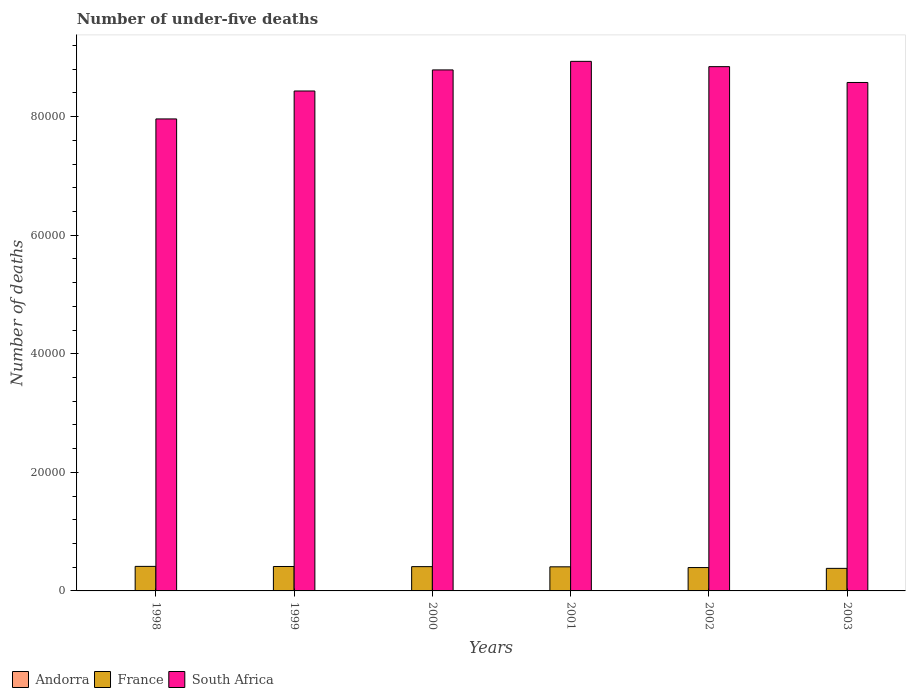How many groups of bars are there?
Ensure brevity in your answer.  6. Are the number of bars on each tick of the X-axis equal?
Offer a terse response. Yes. How many bars are there on the 4th tick from the right?
Your answer should be compact. 3. What is the label of the 3rd group of bars from the left?
Make the answer very short. 2000. Across all years, what is the maximum number of under-five deaths in France?
Your answer should be very brief. 4140. Across all years, what is the minimum number of under-five deaths in France?
Your response must be concise. 3804. In which year was the number of under-five deaths in France maximum?
Make the answer very short. 1998. What is the difference between the number of under-five deaths in France in 1998 and that in 2003?
Provide a succinct answer. 336. What is the difference between the number of under-five deaths in France in 2000 and the number of under-five deaths in Andorra in 1999?
Your response must be concise. 4093. What is the average number of under-five deaths in France per year?
Your answer should be compact. 4027.67. In the year 1998, what is the difference between the number of under-five deaths in South Africa and number of under-five deaths in France?
Give a very brief answer. 7.55e+04. Is the number of under-five deaths in South Africa in 1999 less than that in 2001?
Offer a terse response. Yes. What is the difference between the highest and the second highest number of under-five deaths in France?
Your answer should be compact. 19. What is the difference between the highest and the lowest number of under-five deaths in South Africa?
Ensure brevity in your answer.  9711. Is the sum of the number of under-five deaths in Andorra in 1998 and 2001 greater than the maximum number of under-five deaths in South Africa across all years?
Give a very brief answer. No. What does the 1st bar from the left in 2003 represents?
Make the answer very short. Andorra. What does the 2nd bar from the right in 2003 represents?
Your answer should be very brief. France. Is it the case that in every year, the sum of the number of under-five deaths in Andorra and number of under-five deaths in South Africa is greater than the number of under-five deaths in France?
Ensure brevity in your answer.  Yes. Are all the bars in the graph horizontal?
Ensure brevity in your answer.  No. How many years are there in the graph?
Offer a very short reply. 6. What is the difference between two consecutive major ticks on the Y-axis?
Your answer should be very brief. 2.00e+04. Are the values on the major ticks of Y-axis written in scientific E-notation?
Offer a very short reply. No. Does the graph contain any zero values?
Your response must be concise. No. Where does the legend appear in the graph?
Provide a short and direct response. Bottom left. How many legend labels are there?
Ensure brevity in your answer.  3. How are the legend labels stacked?
Make the answer very short. Horizontal. What is the title of the graph?
Ensure brevity in your answer.  Number of under-five deaths. Does "Turkey" appear as one of the legend labels in the graph?
Ensure brevity in your answer.  No. What is the label or title of the X-axis?
Your response must be concise. Years. What is the label or title of the Y-axis?
Ensure brevity in your answer.  Number of deaths. What is the Number of deaths of France in 1998?
Make the answer very short. 4140. What is the Number of deaths in South Africa in 1998?
Your response must be concise. 7.96e+04. What is the Number of deaths of Andorra in 1999?
Your answer should be compact. 3. What is the Number of deaths of France in 1999?
Provide a short and direct response. 4121. What is the Number of deaths in South Africa in 1999?
Provide a short and direct response. 8.43e+04. What is the Number of deaths in France in 2000?
Provide a succinct answer. 4096. What is the Number of deaths in South Africa in 2000?
Offer a very short reply. 8.79e+04. What is the Number of deaths of Andorra in 2001?
Provide a short and direct response. 3. What is the Number of deaths of France in 2001?
Your answer should be compact. 4065. What is the Number of deaths in South Africa in 2001?
Keep it short and to the point. 8.93e+04. What is the Number of deaths of Andorra in 2002?
Your answer should be compact. 3. What is the Number of deaths in France in 2002?
Give a very brief answer. 3940. What is the Number of deaths in South Africa in 2002?
Your answer should be compact. 8.84e+04. What is the Number of deaths in Andorra in 2003?
Your answer should be very brief. 3. What is the Number of deaths in France in 2003?
Offer a terse response. 3804. What is the Number of deaths in South Africa in 2003?
Provide a succinct answer. 8.58e+04. Across all years, what is the maximum Number of deaths of Andorra?
Keep it short and to the point. 3. Across all years, what is the maximum Number of deaths of France?
Offer a terse response. 4140. Across all years, what is the maximum Number of deaths in South Africa?
Ensure brevity in your answer.  8.93e+04. Across all years, what is the minimum Number of deaths of Andorra?
Give a very brief answer. 3. Across all years, what is the minimum Number of deaths of France?
Keep it short and to the point. 3804. Across all years, what is the minimum Number of deaths of South Africa?
Provide a short and direct response. 7.96e+04. What is the total Number of deaths in Andorra in the graph?
Offer a very short reply. 18. What is the total Number of deaths of France in the graph?
Give a very brief answer. 2.42e+04. What is the total Number of deaths in South Africa in the graph?
Make the answer very short. 5.15e+05. What is the difference between the Number of deaths in Andorra in 1998 and that in 1999?
Give a very brief answer. 0. What is the difference between the Number of deaths in France in 1998 and that in 1999?
Offer a very short reply. 19. What is the difference between the Number of deaths of South Africa in 1998 and that in 1999?
Keep it short and to the point. -4712. What is the difference between the Number of deaths in Andorra in 1998 and that in 2000?
Give a very brief answer. 0. What is the difference between the Number of deaths of South Africa in 1998 and that in 2000?
Your response must be concise. -8266. What is the difference between the Number of deaths in South Africa in 1998 and that in 2001?
Provide a succinct answer. -9711. What is the difference between the Number of deaths in Andorra in 1998 and that in 2002?
Offer a terse response. 0. What is the difference between the Number of deaths in South Africa in 1998 and that in 2002?
Ensure brevity in your answer.  -8818. What is the difference between the Number of deaths of Andorra in 1998 and that in 2003?
Ensure brevity in your answer.  0. What is the difference between the Number of deaths in France in 1998 and that in 2003?
Give a very brief answer. 336. What is the difference between the Number of deaths in South Africa in 1998 and that in 2003?
Provide a short and direct response. -6147. What is the difference between the Number of deaths of Andorra in 1999 and that in 2000?
Your answer should be compact. 0. What is the difference between the Number of deaths in France in 1999 and that in 2000?
Give a very brief answer. 25. What is the difference between the Number of deaths in South Africa in 1999 and that in 2000?
Your response must be concise. -3554. What is the difference between the Number of deaths in France in 1999 and that in 2001?
Give a very brief answer. 56. What is the difference between the Number of deaths of South Africa in 1999 and that in 2001?
Your answer should be compact. -4999. What is the difference between the Number of deaths in France in 1999 and that in 2002?
Your response must be concise. 181. What is the difference between the Number of deaths of South Africa in 1999 and that in 2002?
Ensure brevity in your answer.  -4106. What is the difference between the Number of deaths of Andorra in 1999 and that in 2003?
Provide a succinct answer. 0. What is the difference between the Number of deaths in France in 1999 and that in 2003?
Offer a very short reply. 317. What is the difference between the Number of deaths of South Africa in 1999 and that in 2003?
Your answer should be very brief. -1435. What is the difference between the Number of deaths of France in 2000 and that in 2001?
Offer a terse response. 31. What is the difference between the Number of deaths of South Africa in 2000 and that in 2001?
Keep it short and to the point. -1445. What is the difference between the Number of deaths in Andorra in 2000 and that in 2002?
Provide a short and direct response. 0. What is the difference between the Number of deaths of France in 2000 and that in 2002?
Ensure brevity in your answer.  156. What is the difference between the Number of deaths of South Africa in 2000 and that in 2002?
Your response must be concise. -552. What is the difference between the Number of deaths of Andorra in 2000 and that in 2003?
Your answer should be compact. 0. What is the difference between the Number of deaths in France in 2000 and that in 2003?
Offer a very short reply. 292. What is the difference between the Number of deaths in South Africa in 2000 and that in 2003?
Provide a short and direct response. 2119. What is the difference between the Number of deaths of France in 2001 and that in 2002?
Offer a very short reply. 125. What is the difference between the Number of deaths in South Africa in 2001 and that in 2002?
Provide a short and direct response. 893. What is the difference between the Number of deaths in Andorra in 2001 and that in 2003?
Provide a succinct answer. 0. What is the difference between the Number of deaths in France in 2001 and that in 2003?
Your answer should be compact. 261. What is the difference between the Number of deaths of South Africa in 2001 and that in 2003?
Your answer should be compact. 3564. What is the difference between the Number of deaths of France in 2002 and that in 2003?
Give a very brief answer. 136. What is the difference between the Number of deaths in South Africa in 2002 and that in 2003?
Ensure brevity in your answer.  2671. What is the difference between the Number of deaths of Andorra in 1998 and the Number of deaths of France in 1999?
Your response must be concise. -4118. What is the difference between the Number of deaths of Andorra in 1998 and the Number of deaths of South Africa in 1999?
Keep it short and to the point. -8.43e+04. What is the difference between the Number of deaths of France in 1998 and the Number of deaths of South Africa in 1999?
Give a very brief answer. -8.02e+04. What is the difference between the Number of deaths in Andorra in 1998 and the Number of deaths in France in 2000?
Your answer should be very brief. -4093. What is the difference between the Number of deaths in Andorra in 1998 and the Number of deaths in South Africa in 2000?
Make the answer very short. -8.79e+04. What is the difference between the Number of deaths of France in 1998 and the Number of deaths of South Africa in 2000?
Keep it short and to the point. -8.37e+04. What is the difference between the Number of deaths of Andorra in 1998 and the Number of deaths of France in 2001?
Your answer should be very brief. -4062. What is the difference between the Number of deaths of Andorra in 1998 and the Number of deaths of South Africa in 2001?
Your answer should be compact. -8.93e+04. What is the difference between the Number of deaths of France in 1998 and the Number of deaths of South Africa in 2001?
Your answer should be compact. -8.52e+04. What is the difference between the Number of deaths of Andorra in 1998 and the Number of deaths of France in 2002?
Provide a succinct answer. -3937. What is the difference between the Number of deaths of Andorra in 1998 and the Number of deaths of South Africa in 2002?
Make the answer very short. -8.84e+04. What is the difference between the Number of deaths of France in 1998 and the Number of deaths of South Africa in 2002?
Make the answer very short. -8.43e+04. What is the difference between the Number of deaths in Andorra in 1998 and the Number of deaths in France in 2003?
Provide a short and direct response. -3801. What is the difference between the Number of deaths of Andorra in 1998 and the Number of deaths of South Africa in 2003?
Keep it short and to the point. -8.58e+04. What is the difference between the Number of deaths in France in 1998 and the Number of deaths in South Africa in 2003?
Provide a succinct answer. -8.16e+04. What is the difference between the Number of deaths in Andorra in 1999 and the Number of deaths in France in 2000?
Your answer should be compact. -4093. What is the difference between the Number of deaths in Andorra in 1999 and the Number of deaths in South Africa in 2000?
Your answer should be compact. -8.79e+04. What is the difference between the Number of deaths of France in 1999 and the Number of deaths of South Africa in 2000?
Give a very brief answer. -8.38e+04. What is the difference between the Number of deaths of Andorra in 1999 and the Number of deaths of France in 2001?
Your answer should be compact. -4062. What is the difference between the Number of deaths in Andorra in 1999 and the Number of deaths in South Africa in 2001?
Make the answer very short. -8.93e+04. What is the difference between the Number of deaths in France in 1999 and the Number of deaths in South Africa in 2001?
Make the answer very short. -8.52e+04. What is the difference between the Number of deaths of Andorra in 1999 and the Number of deaths of France in 2002?
Ensure brevity in your answer.  -3937. What is the difference between the Number of deaths in Andorra in 1999 and the Number of deaths in South Africa in 2002?
Make the answer very short. -8.84e+04. What is the difference between the Number of deaths of France in 1999 and the Number of deaths of South Africa in 2002?
Provide a succinct answer. -8.43e+04. What is the difference between the Number of deaths of Andorra in 1999 and the Number of deaths of France in 2003?
Make the answer very short. -3801. What is the difference between the Number of deaths of Andorra in 1999 and the Number of deaths of South Africa in 2003?
Your response must be concise. -8.58e+04. What is the difference between the Number of deaths in France in 1999 and the Number of deaths in South Africa in 2003?
Provide a succinct answer. -8.16e+04. What is the difference between the Number of deaths of Andorra in 2000 and the Number of deaths of France in 2001?
Provide a short and direct response. -4062. What is the difference between the Number of deaths of Andorra in 2000 and the Number of deaths of South Africa in 2001?
Keep it short and to the point. -8.93e+04. What is the difference between the Number of deaths in France in 2000 and the Number of deaths in South Africa in 2001?
Your response must be concise. -8.52e+04. What is the difference between the Number of deaths in Andorra in 2000 and the Number of deaths in France in 2002?
Offer a very short reply. -3937. What is the difference between the Number of deaths in Andorra in 2000 and the Number of deaths in South Africa in 2002?
Provide a short and direct response. -8.84e+04. What is the difference between the Number of deaths in France in 2000 and the Number of deaths in South Africa in 2002?
Keep it short and to the point. -8.43e+04. What is the difference between the Number of deaths of Andorra in 2000 and the Number of deaths of France in 2003?
Offer a terse response. -3801. What is the difference between the Number of deaths of Andorra in 2000 and the Number of deaths of South Africa in 2003?
Your answer should be very brief. -8.58e+04. What is the difference between the Number of deaths of France in 2000 and the Number of deaths of South Africa in 2003?
Your answer should be compact. -8.17e+04. What is the difference between the Number of deaths of Andorra in 2001 and the Number of deaths of France in 2002?
Offer a very short reply. -3937. What is the difference between the Number of deaths of Andorra in 2001 and the Number of deaths of South Africa in 2002?
Offer a terse response. -8.84e+04. What is the difference between the Number of deaths of France in 2001 and the Number of deaths of South Africa in 2002?
Give a very brief answer. -8.44e+04. What is the difference between the Number of deaths in Andorra in 2001 and the Number of deaths in France in 2003?
Offer a very short reply. -3801. What is the difference between the Number of deaths of Andorra in 2001 and the Number of deaths of South Africa in 2003?
Your answer should be very brief. -8.58e+04. What is the difference between the Number of deaths of France in 2001 and the Number of deaths of South Africa in 2003?
Your response must be concise. -8.17e+04. What is the difference between the Number of deaths of Andorra in 2002 and the Number of deaths of France in 2003?
Make the answer very short. -3801. What is the difference between the Number of deaths in Andorra in 2002 and the Number of deaths in South Africa in 2003?
Your answer should be very brief. -8.58e+04. What is the difference between the Number of deaths of France in 2002 and the Number of deaths of South Africa in 2003?
Provide a succinct answer. -8.18e+04. What is the average Number of deaths in France per year?
Ensure brevity in your answer.  4027.67. What is the average Number of deaths of South Africa per year?
Ensure brevity in your answer.  8.59e+04. In the year 1998, what is the difference between the Number of deaths in Andorra and Number of deaths in France?
Your response must be concise. -4137. In the year 1998, what is the difference between the Number of deaths of Andorra and Number of deaths of South Africa?
Keep it short and to the point. -7.96e+04. In the year 1998, what is the difference between the Number of deaths in France and Number of deaths in South Africa?
Your answer should be compact. -7.55e+04. In the year 1999, what is the difference between the Number of deaths in Andorra and Number of deaths in France?
Your answer should be compact. -4118. In the year 1999, what is the difference between the Number of deaths of Andorra and Number of deaths of South Africa?
Keep it short and to the point. -8.43e+04. In the year 1999, what is the difference between the Number of deaths of France and Number of deaths of South Africa?
Keep it short and to the point. -8.02e+04. In the year 2000, what is the difference between the Number of deaths in Andorra and Number of deaths in France?
Provide a succinct answer. -4093. In the year 2000, what is the difference between the Number of deaths of Andorra and Number of deaths of South Africa?
Your response must be concise. -8.79e+04. In the year 2000, what is the difference between the Number of deaths of France and Number of deaths of South Africa?
Give a very brief answer. -8.38e+04. In the year 2001, what is the difference between the Number of deaths of Andorra and Number of deaths of France?
Offer a very short reply. -4062. In the year 2001, what is the difference between the Number of deaths in Andorra and Number of deaths in South Africa?
Your answer should be very brief. -8.93e+04. In the year 2001, what is the difference between the Number of deaths of France and Number of deaths of South Africa?
Offer a terse response. -8.53e+04. In the year 2002, what is the difference between the Number of deaths in Andorra and Number of deaths in France?
Your response must be concise. -3937. In the year 2002, what is the difference between the Number of deaths in Andorra and Number of deaths in South Africa?
Offer a terse response. -8.84e+04. In the year 2002, what is the difference between the Number of deaths in France and Number of deaths in South Africa?
Your answer should be very brief. -8.45e+04. In the year 2003, what is the difference between the Number of deaths in Andorra and Number of deaths in France?
Offer a terse response. -3801. In the year 2003, what is the difference between the Number of deaths in Andorra and Number of deaths in South Africa?
Keep it short and to the point. -8.58e+04. In the year 2003, what is the difference between the Number of deaths of France and Number of deaths of South Africa?
Your response must be concise. -8.20e+04. What is the ratio of the Number of deaths in Andorra in 1998 to that in 1999?
Offer a terse response. 1. What is the ratio of the Number of deaths in South Africa in 1998 to that in 1999?
Your answer should be very brief. 0.94. What is the ratio of the Number of deaths in France in 1998 to that in 2000?
Offer a very short reply. 1.01. What is the ratio of the Number of deaths of South Africa in 1998 to that in 2000?
Provide a short and direct response. 0.91. What is the ratio of the Number of deaths of France in 1998 to that in 2001?
Your answer should be compact. 1.02. What is the ratio of the Number of deaths of South Africa in 1998 to that in 2001?
Provide a short and direct response. 0.89. What is the ratio of the Number of deaths in France in 1998 to that in 2002?
Offer a very short reply. 1.05. What is the ratio of the Number of deaths in South Africa in 1998 to that in 2002?
Your answer should be compact. 0.9. What is the ratio of the Number of deaths of France in 1998 to that in 2003?
Provide a succinct answer. 1.09. What is the ratio of the Number of deaths in South Africa in 1998 to that in 2003?
Give a very brief answer. 0.93. What is the ratio of the Number of deaths of Andorra in 1999 to that in 2000?
Offer a very short reply. 1. What is the ratio of the Number of deaths in South Africa in 1999 to that in 2000?
Your response must be concise. 0.96. What is the ratio of the Number of deaths of France in 1999 to that in 2001?
Keep it short and to the point. 1.01. What is the ratio of the Number of deaths of South Africa in 1999 to that in 2001?
Your response must be concise. 0.94. What is the ratio of the Number of deaths of Andorra in 1999 to that in 2002?
Make the answer very short. 1. What is the ratio of the Number of deaths in France in 1999 to that in 2002?
Provide a short and direct response. 1.05. What is the ratio of the Number of deaths of South Africa in 1999 to that in 2002?
Your answer should be very brief. 0.95. What is the ratio of the Number of deaths in France in 1999 to that in 2003?
Keep it short and to the point. 1.08. What is the ratio of the Number of deaths of South Africa in 1999 to that in 2003?
Your answer should be very brief. 0.98. What is the ratio of the Number of deaths of Andorra in 2000 to that in 2001?
Provide a short and direct response. 1. What is the ratio of the Number of deaths of France in 2000 to that in 2001?
Your answer should be compact. 1.01. What is the ratio of the Number of deaths of South Africa in 2000 to that in 2001?
Give a very brief answer. 0.98. What is the ratio of the Number of deaths in France in 2000 to that in 2002?
Give a very brief answer. 1.04. What is the ratio of the Number of deaths of Andorra in 2000 to that in 2003?
Your response must be concise. 1. What is the ratio of the Number of deaths in France in 2000 to that in 2003?
Provide a short and direct response. 1.08. What is the ratio of the Number of deaths in South Africa in 2000 to that in 2003?
Ensure brevity in your answer.  1.02. What is the ratio of the Number of deaths in Andorra in 2001 to that in 2002?
Your answer should be very brief. 1. What is the ratio of the Number of deaths in France in 2001 to that in 2002?
Ensure brevity in your answer.  1.03. What is the ratio of the Number of deaths of Andorra in 2001 to that in 2003?
Give a very brief answer. 1. What is the ratio of the Number of deaths of France in 2001 to that in 2003?
Your answer should be compact. 1.07. What is the ratio of the Number of deaths of South Africa in 2001 to that in 2003?
Ensure brevity in your answer.  1.04. What is the ratio of the Number of deaths in France in 2002 to that in 2003?
Give a very brief answer. 1.04. What is the ratio of the Number of deaths in South Africa in 2002 to that in 2003?
Provide a succinct answer. 1.03. What is the difference between the highest and the second highest Number of deaths in Andorra?
Give a very brief answer. 0. What is the difference between the highest and the second highest Number of deaths in South Africa?
Your answer should be very brief. 893. What is the difference between the highest and the lowest Number of deaths in Andorra?
Make the answer very short. 0. What is the difference between the highest and the lowest Number of deaths in France?
Give a very brief answer. 336. What is the difference between the highest and the lowest Number of deaths in South Africa?
Make the answer very short. 9711. 